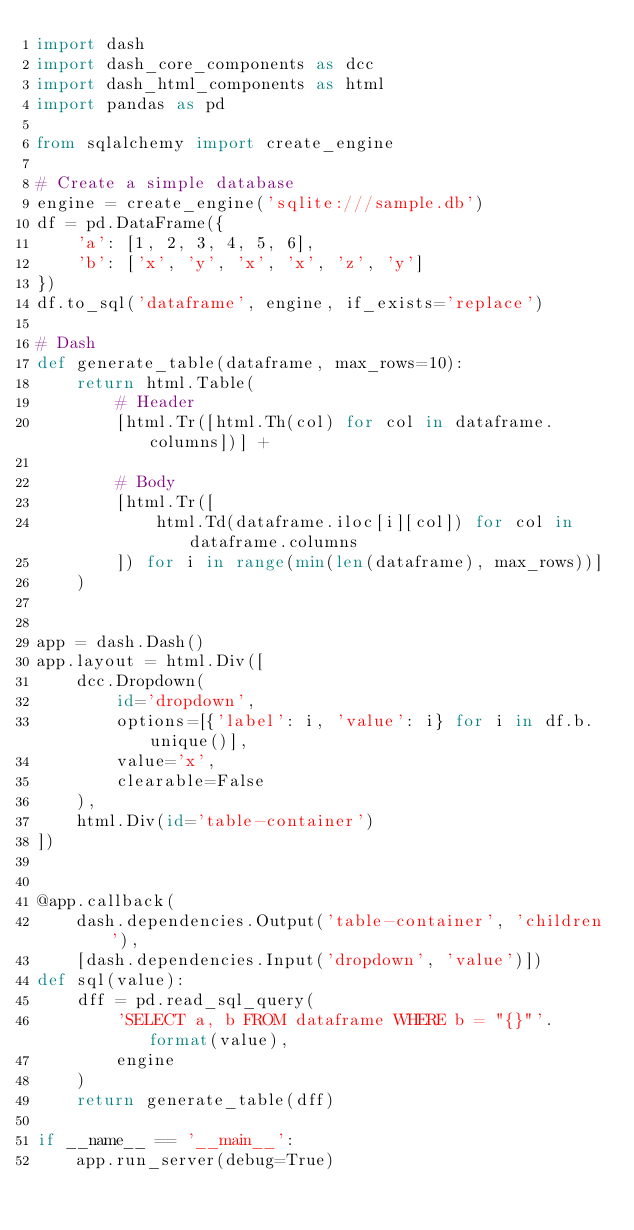Convert code to text. <code><loc_0><loc_0><loc_500><loc_500><_Python_>import dash
import dash_core_components as dcc
import dash_html_components as html
import pandas as pd

from sqlalchemy import create_engine

# Create a simple database
engine = create_engine('sqlite:///sample.db')
df = pd.DataFrame({
    'a': [1, 2, 3, 4, 5, 6],
    'b': ['x', 'y', 'x', 'x', 'z', 'y']
})
df.to_sql('dataframe', engine, if_exists='replace')

# Dash
def generate_table(dataframe, max_rows=10):
    return html.Table(
        # Header
        [html.Tr([html.Th(col) for col in dataframe.columns])] +

        # Body
        [html.Tr([
            html.Td(dataframe.iloc[i][col]) for col in dataframe.columns
        ]) for i in range(min(len(dataframe), max_rows))]
    )


app = dash.Dash()
app.layout = html.Div([
    dcc.Dropdown(
        id='dropdown',
        options=[{'label': i, 'value': i} for i in df.b.unique()],
        value='x',
        clearable=False
    ),
    html.Div(id='table-container')
])


@app.callback(
    dash.dependencies.Output('table-container', 'children'),
    [dash.dependencies.Input('dropdown', 'value')])
def sql(value):
    dff = pd.read_sql_query(
        'SELECT a, b FROM dataframe WHERE b = "{}"'.format(value),
        engine
    )
    return generate_table(dff)

if __name__ == '__main__':
    app.run_server(debug=True)
</code> 